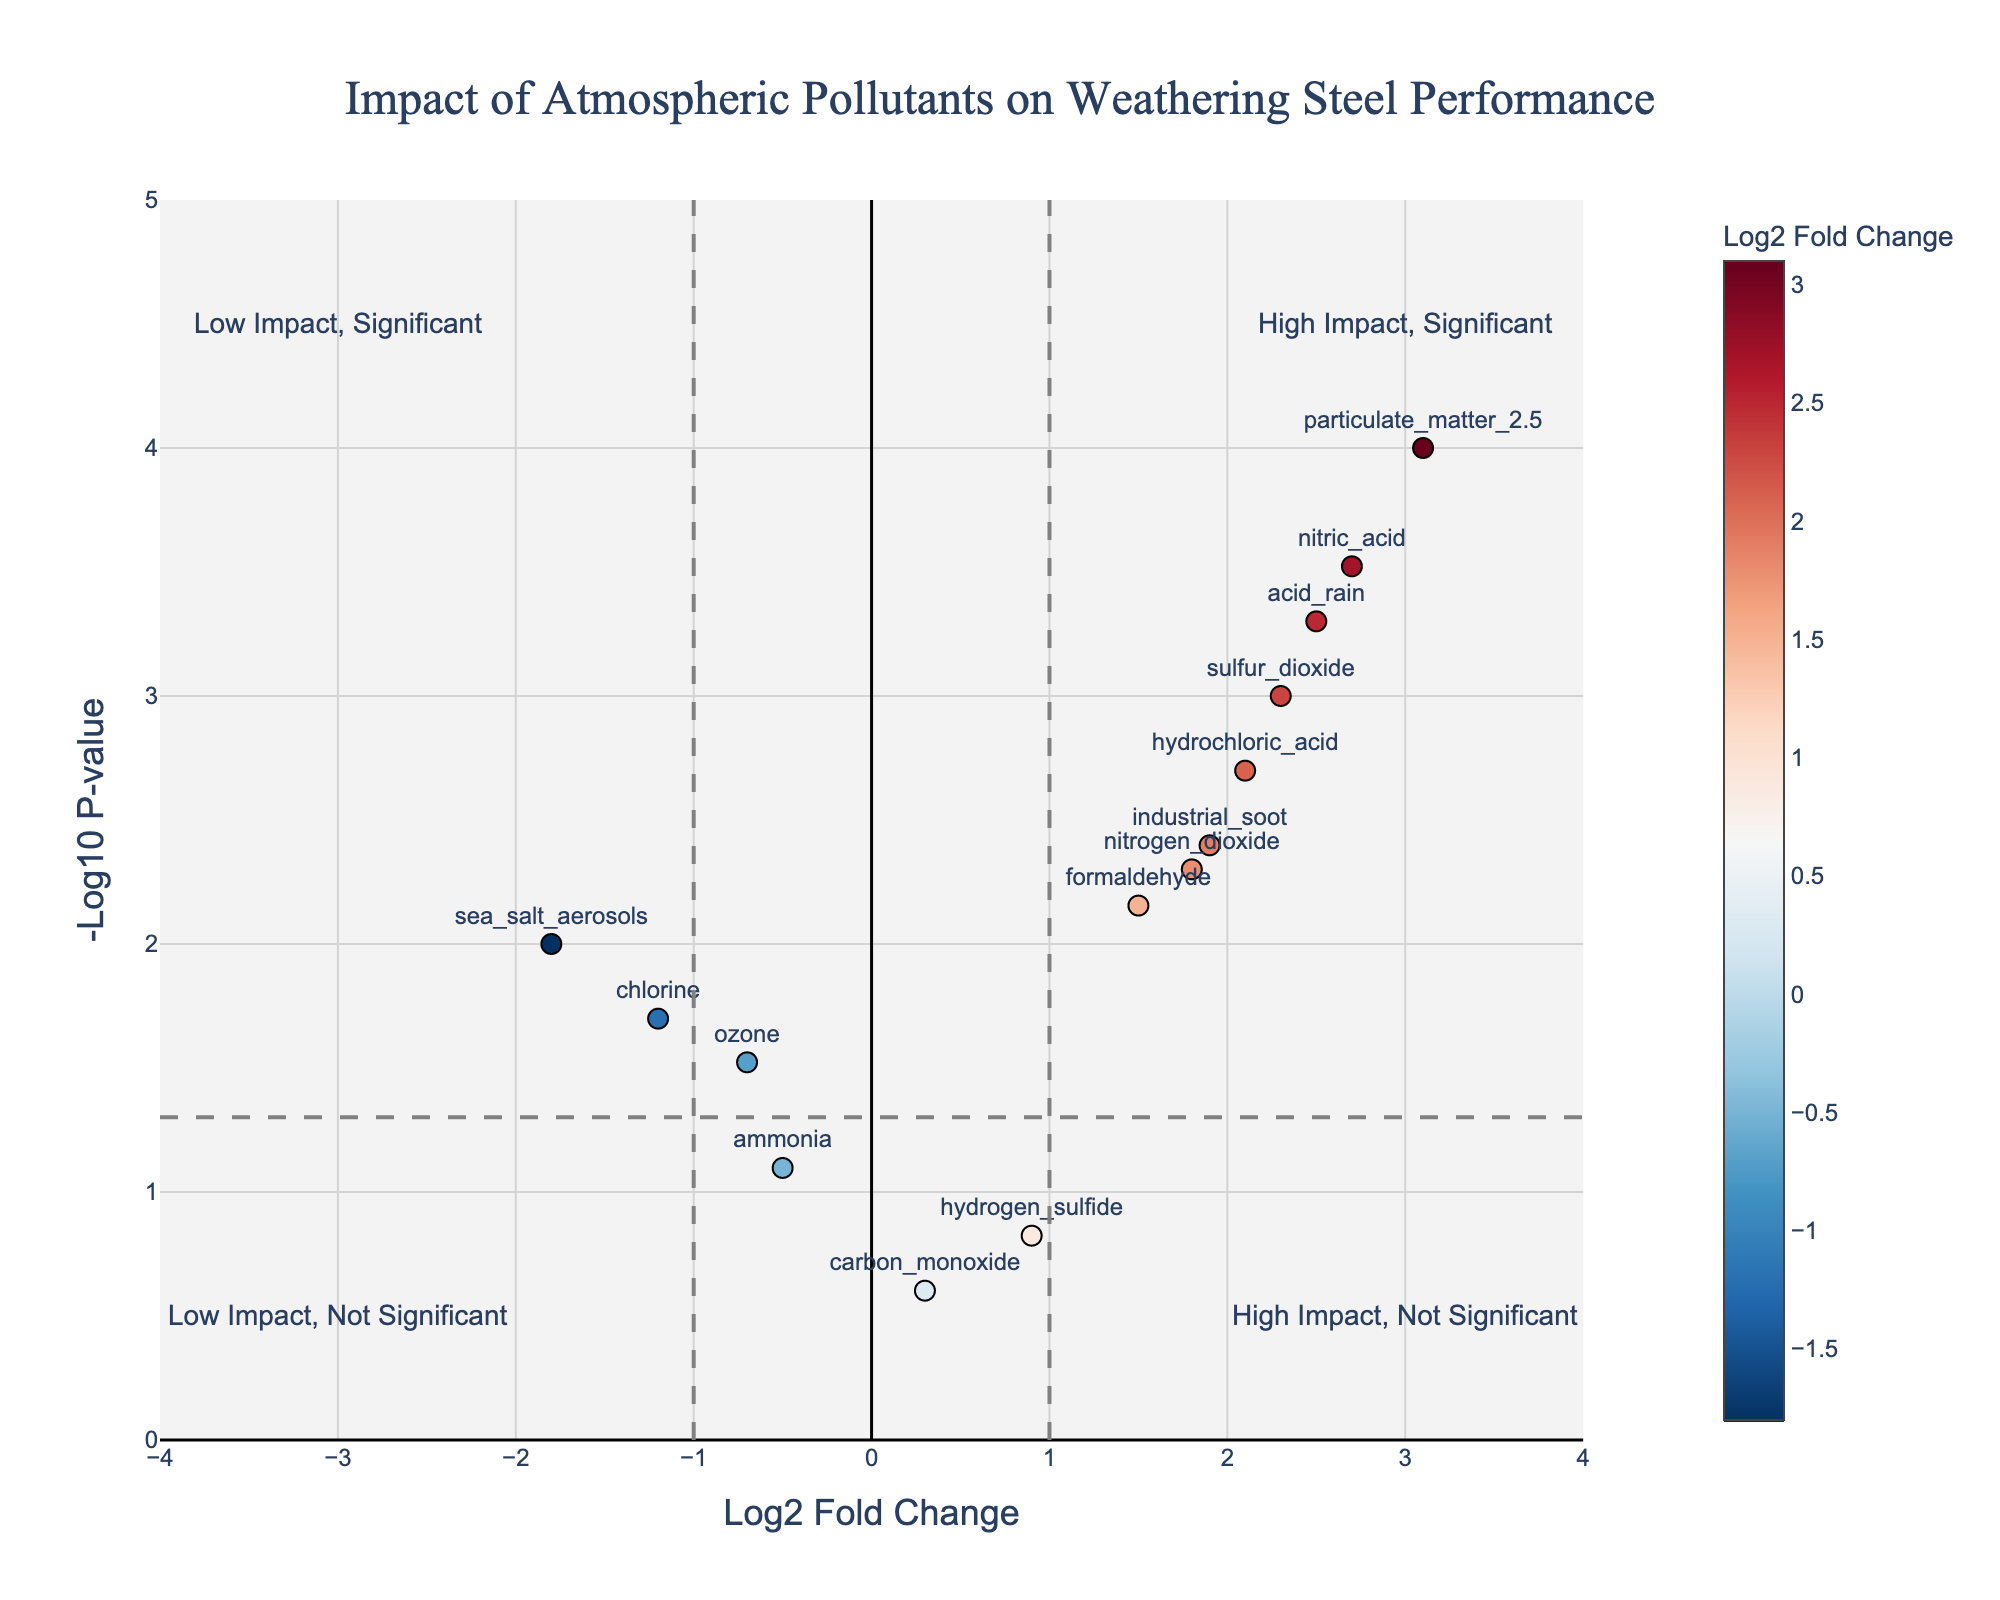What is the title of the plot? The title of the plot is displayed at the top center. It reads "Impact of Atmospheric Pollutants on Weathering Steel Performance".
Answer: Impact of Atmospheric Pollutants on Weathering Steel Performance How many data points are on the plot? To determine the number of data points, count the markers on the plot. Each marker represents a different pollutant. There are 14 markers on the plot, corresponding to the 14 pollutants listed in the data.
Answer: 14 Which pollutant has the highest log2 fold change? Look at the x-axis for the marker farthest to the right. Each marker indicates a different pollutant. The furthest right marker corresponds to "particulate_matter_2.5" with a log2 fold change of 3.1.
Answer: particulate_matter_2.5 Which pollutant has the lowest p-value and how can you tell? The pollutant with the lowest p-value will have the highest -log10(p-value) on the y-axis. Locate the marker highest on the y-axis, which corresponds to "particulate_matter_2.5" with a p-value of 0.0001.
Answer: particulate_matter_2.5 What is the significance threshold for the p-value on the plot? The significance threshold for the p-value is represented by a horizontal dashed line. This line corresponds to a p-value of 0.05, which is marked on the y-axis as -log10(0.05).
Answer: 0.05 Which pollutants are in the "High Impact, Significant" quadrant? The "High Impact, Significant" quadrant is to the upper right of the vertical threshold line at log2 fold change of 1 and above the horizontal threshold line at -log10(p-value) of 1.3. The pollutants in this quadrant are: sulfur_dioxide, nitrogen_dioxide, particulate_matter_2.5, nitric_acid, hydrochloric_acid, industrial_soot, acid_rain.
Answer: sulfur_dioxide, nitrogen_dioxide, particulate_matter_2.5, nitric_acid, hydrochloric_acid, industrial_soot, acid_rain Which pollutant has a negative log2 fold change and is significant? Look for pollutants on the left side of the plot (negative log2 fold change) that are above the p-value significance threshold line (-log10(p-value) = 1.3). The pollutants that meet this criteria are ozone, chlorine, and sea_salt_aerosols.
Answer: ozone, chlorine, sea_salt_aerosols What is the log2 fold change of formaldehyde, and is it significant? Find the marker labeled "formaldehyde" and check its x-coordinate for the log2 fold change and its y-coordinate against the significance threshold. Formaldehyde has a log2 fold change of 1.5 and is above the significance threshold, making it significant.
Answer: 1.5, significant Which two pollutants have the closest log2 fold changes but different significance levels? Compare the log2 fold changes and significance levels of the pollutants. Carbon_monoxide (0.3) and Hydrogen_sulfide (0.9) have close log2 fold changes, but different significance levels; carbon_monoxide is not significant (p-value > 0.05) while hydrogen_sulfide is close to not significant.
Answer: Carbon_monoxide, Hydrogen_sulfide Which pollutant has the second highest -log10(p-value)? Find the pollutant with the second highest point on the y-axis after particulate_matter_2.5. The pollutant is sulfur_dioxide with a high -log10(p-value).
Answer: sulfur_dioxide 